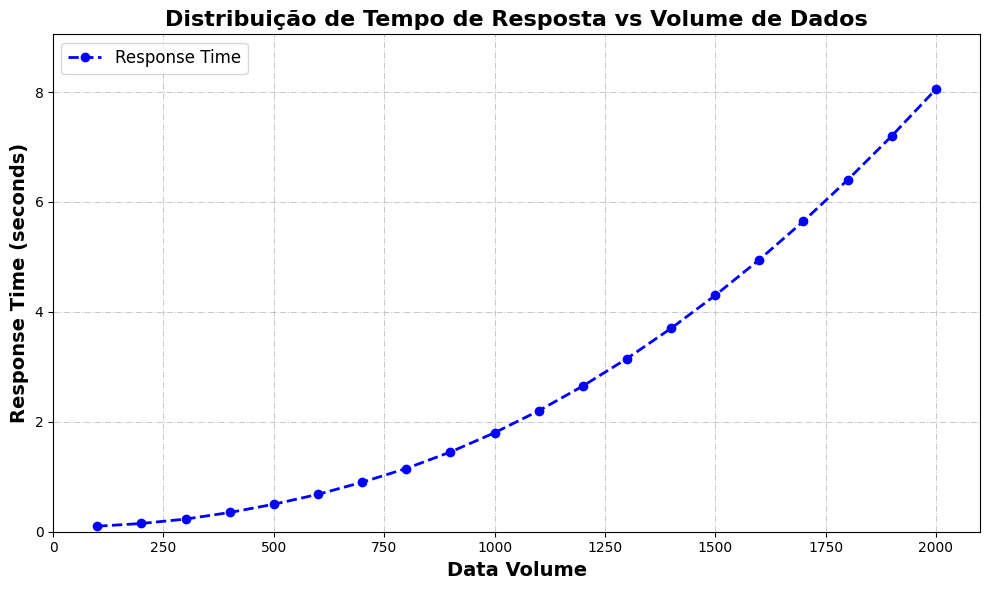What is the response time for a data volume of 1000 units? The response time for a data volume of 1000 units can be read directly from the plot.
Answer: 1.8 seconds What is the difference in response time between a data volume of 500 and 1500 units? The response time at 500 units is 0.5 seconds, and at 1500 units is 4.3 seconds. The difference is 4.3 - 0.5 = 3.8 seconds.
Answer: 3.8 seconds How does the response time change as the data volume increases from 800 to 1200 units? The response time increases from 1.15 seconds at 800 units to 2.65 seconds at 1200 units. This is an increase of 2.65 - 1.15 = 1.5 seconds.
Answer: Increases by 1.5 seconds Which data volume corresponds to a response time of approximately 7.2 seconds? Observing the plot, the response time of 7.2 seconds corresponds to a data volume of around 1900 units.
Answer: 1900 units Is there a point where the response time doubles compared to an earlier data volume? Yes, for instance, from 500 units (0.5 seconds) to 1000 units (1.8 seconds) although it slightly more than double, it shows a significant increase, indicating an exponential-like increase as the volume grows.
Answer: Roughly at a 1000 units By how much does the response time increase when the data volume is increased from 100 units to 600 units? The response time at 100 units is 0.1 seconds and at 600 units is 0.68 seconds. The increase is 0.68 - 0.1 = 0.58 seconds.
Answer: 0.58 seconds At what data volume does the response time start to exceed 1 second? From the plot, observe where the response time curve exceeds 1 second. This occurs around 800 units.
Answer: 800 units How would you describe the trend of the response time as the data volume increases? The response time increases steadily and appears to curve upwards, indicating a nonlinear relationship where the response time becomes significantly larger as the data volume increases.
Answer: Nonlinear, increasing trend Estimate the average response time for data volumes between 1000 and 1500 units. The response times for data volumes 1000, 1100, 1200, 1300, 1400, and 1500 units are 1.8, 2.2, 2.65, 3.15, 3.7, and 4.3 seconds. The sum is 17.8 seconds, and the average is 17.8/6 ≈ 2.97 seconds.
Answer: Approximately 2.97 seconds 